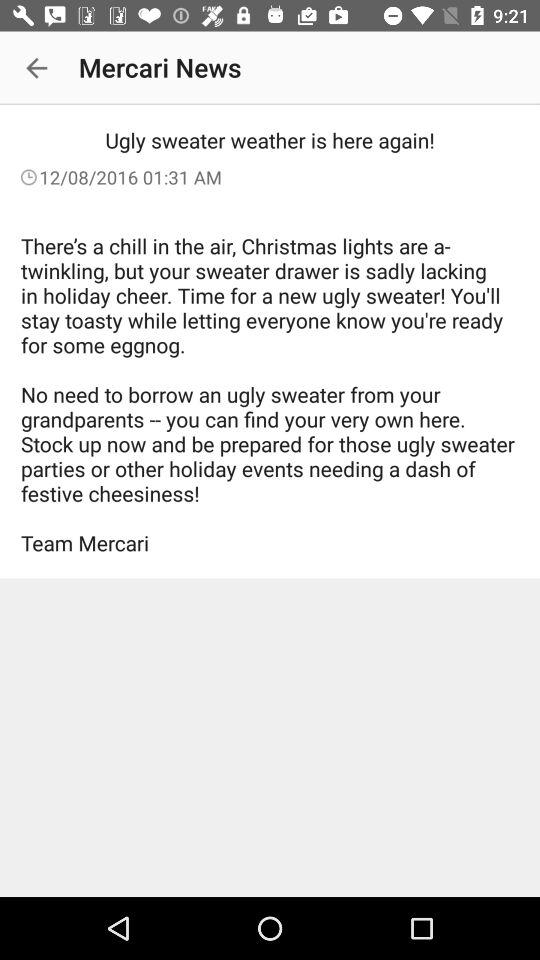Who's the publisher of the news article? The publisher of the news article is "Mercari". 